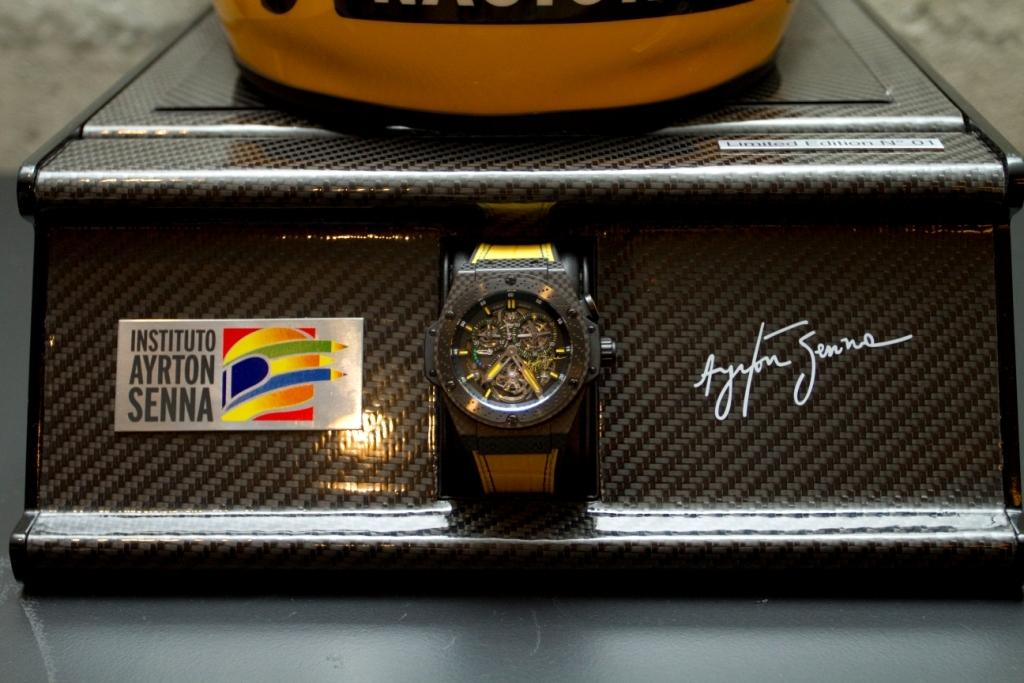Provide a one-sentence caption for the provided image. A watch display stand that has been signed by Senna. 